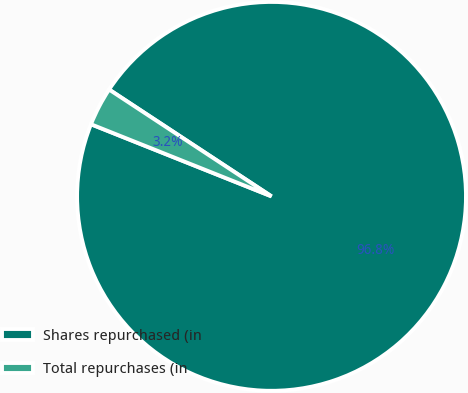Convert chart. <chart><loc_0><loc_0><loc_500><loc_500><pie_chart><fcel>Shares repurchased (in<fcel>Total repurchases (in<nl><fcel>96.79%<fcel>3.21%<nl></chart> 